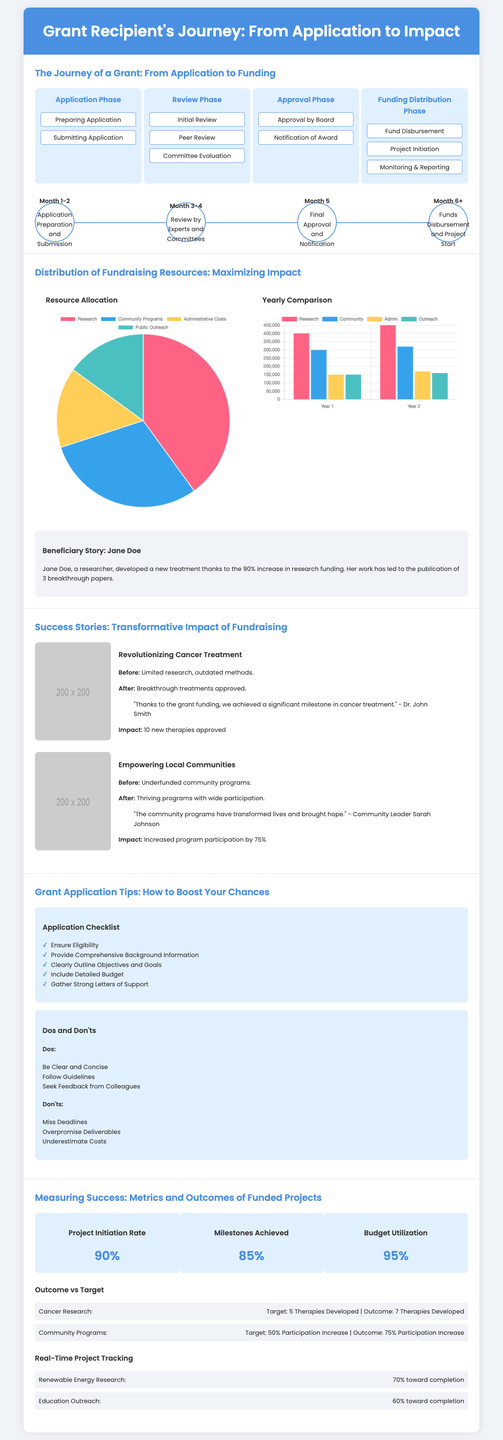What are the phases of the grant journey? The phases of the grant journey include Application Phase, Review Phase, Approval Phase, and Funding Distribution Phase.
Answer: Application, Review, Approval, Distribution How many new therapies were approved for cancer research? The document states that there were 10 new therapies approved as a result of the project.
Answer: 10 What percentage of budget utilization is reported? The document provides the budget utilization figure as a KPI showing 95% utilization.
Answer: 95% What was the increase in participation for community programs? The document indicates an increase in participation by 75% in community programs compared to the target.
Answer: 75% What type of graph represents the yearly comparison of fundraising resources? The document uses a bar graph to represent the yearly comparison of fundraising resources.
Answer: Bar graph How many therapies were developed for cancer research according to outcome vs target? The document specifies that 7 therapies were developed compared to the target of 5.
Answer: 7 Which milestone occurs after "Fund Disbursement" in the funding distribution phase? The next milestone after "Fund Disbursement" is "Project Initiation."
Answer: Project Initiation What is one of the dos for writing a successful grant application? The document advises to be clear and concise as one of the dos for successful applications.
Answer: Be clear and concise What is the total number of milestones achieved? The key performance indicator (KPI) indicates that 85% of milestones have been achieved.
Answer: 85% 